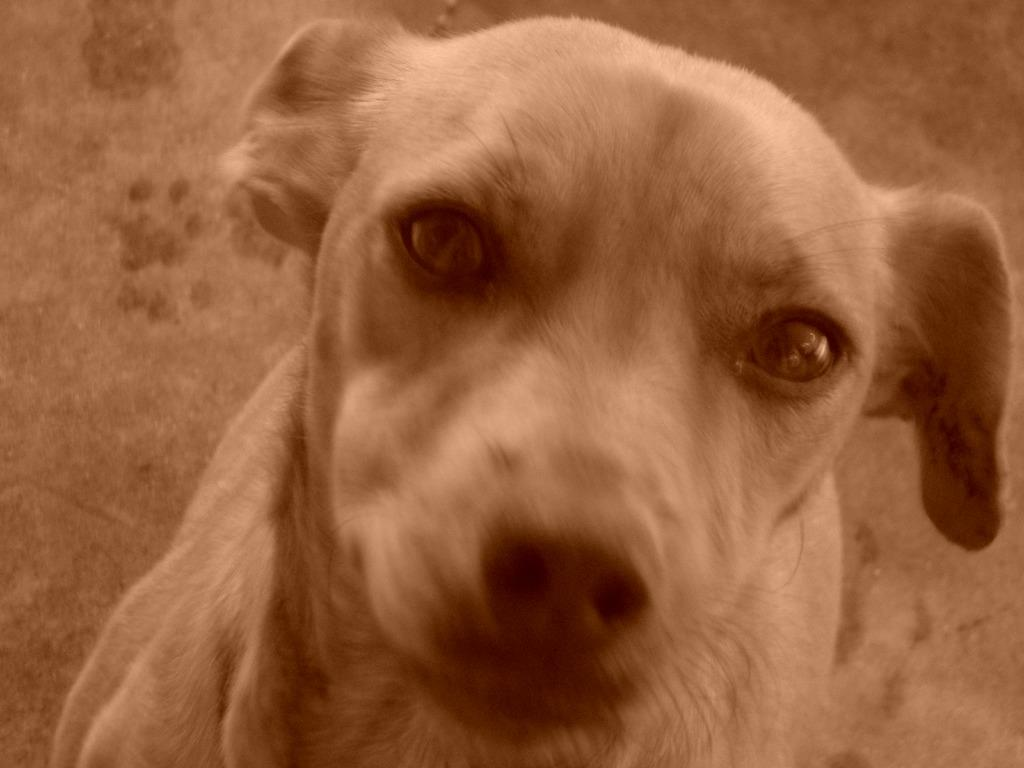What animal is in the image? There is a dog in the image. Where is the dog located in the image? The dog is in the center of the image. What color is the dog? The dog is brown in color. What type of fiction is the dog reading in the image? There is no fiction present in the image, as it features a dog that is not engaged in any reading activity. 